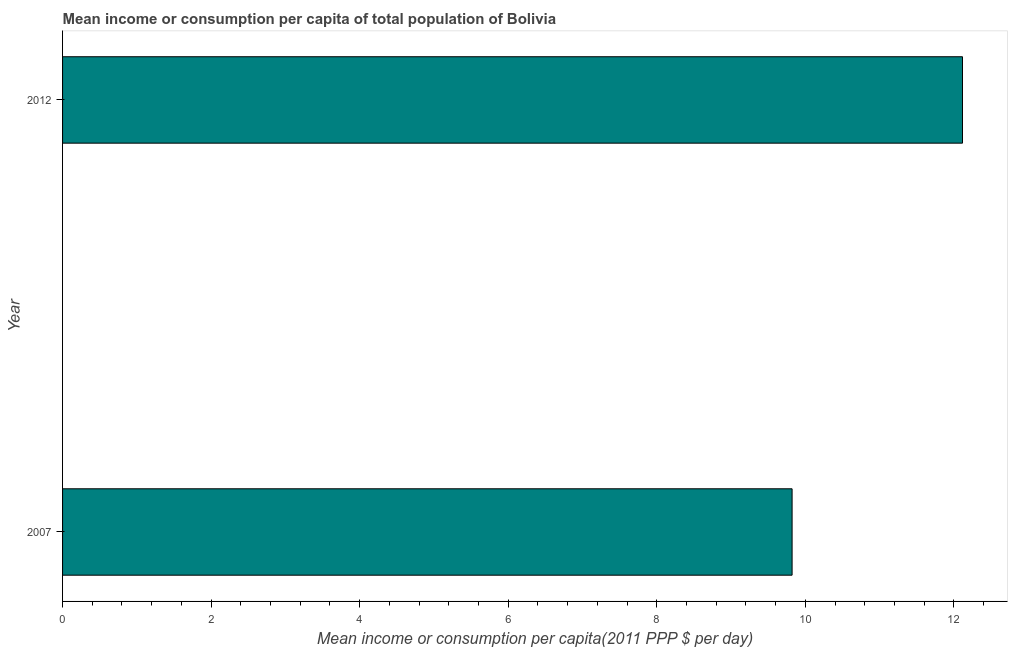Does the graph contain grids?
Provide a short and direct response. No. What is the title of the graph?
Provide a short and direct response. Mean income or consumption per capita of total population of Bolivia. What is the label or title of the X-axis?
Provide a short and direct response. Mean income or consumption per capita(2011 PPP $ per day). What is the mean income or consumption in 2012?
Offer a very short reply. 12.12. Across all years, what is the maximum mean income or consumption?
Offer a terse response. 12.12. Across all years, what is the minimum mean income or consumption?
Your answer should be very brief. 9.82. In which year was the mean income or consumption minimum?
Offer a terse response. 2007. What is the sum of the mean income or consumption?
Provide a short and direct response. 21.94. What is the difference between the mean income or consumption in 2007 and 2012?
Provide a short and direct response. -2.29. What is the average mean income or consumption per year?
Provide a short and direct response. 10.97. What is the median mean income or consumption?
Your answer should be very brief. 10.97. What is the ratio of the mean income or consumption in 2007 to that in 2012?
Provide a short and direct response. 0.81. Is the mean income or consumption in 2007 less than that in 2012?
Provide a succinct answer. Yes. How many bars are there?
Your response must be concise. 2. Are all the bars in the graph horizontal?
Provide a short and direct response. Yes. How many years are there in the graph?
Your response must be concise. 2. Are the values on the major ticks of X-axis written in scientific E-notation?
Offer a very short reply. No. What is the Mean income or consumption per capita(2011 PPP $ per day) in 2007?
Make the answer very short. 9.82. What is the Mean income or consumption per capita(2011 PPP $ per day) of 2012?
Your answer should be very brief. 12.12. What is the difference between the Mean income or consumption per capita(2011 PPP $ per day) in 2007 and 2012?
Offer a very short reply. -2.29. What is the ratio of the Mean income or consumption per capita(2011 PPP $ per day) in 2007 to that in 2012?
Keep it short and to the point. 0.81. 